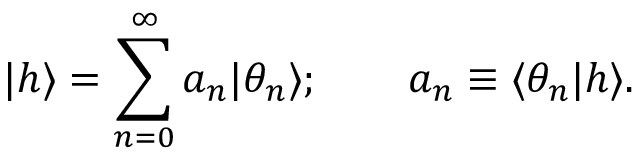Convert formula to latex. <formula><loc_0><loc_0><loc_500><loc_500>| h \rangle = \sum _ { n = 0 } ^ { \infty } a _ { n } | \theta _ { n } \rangle ; \quad a _ { n } \equiv \langle \theta _ { n } | h \rangle .</formula> 